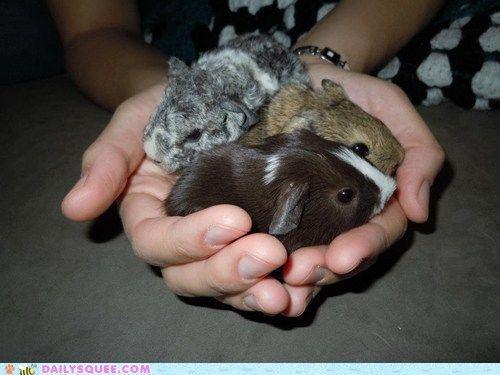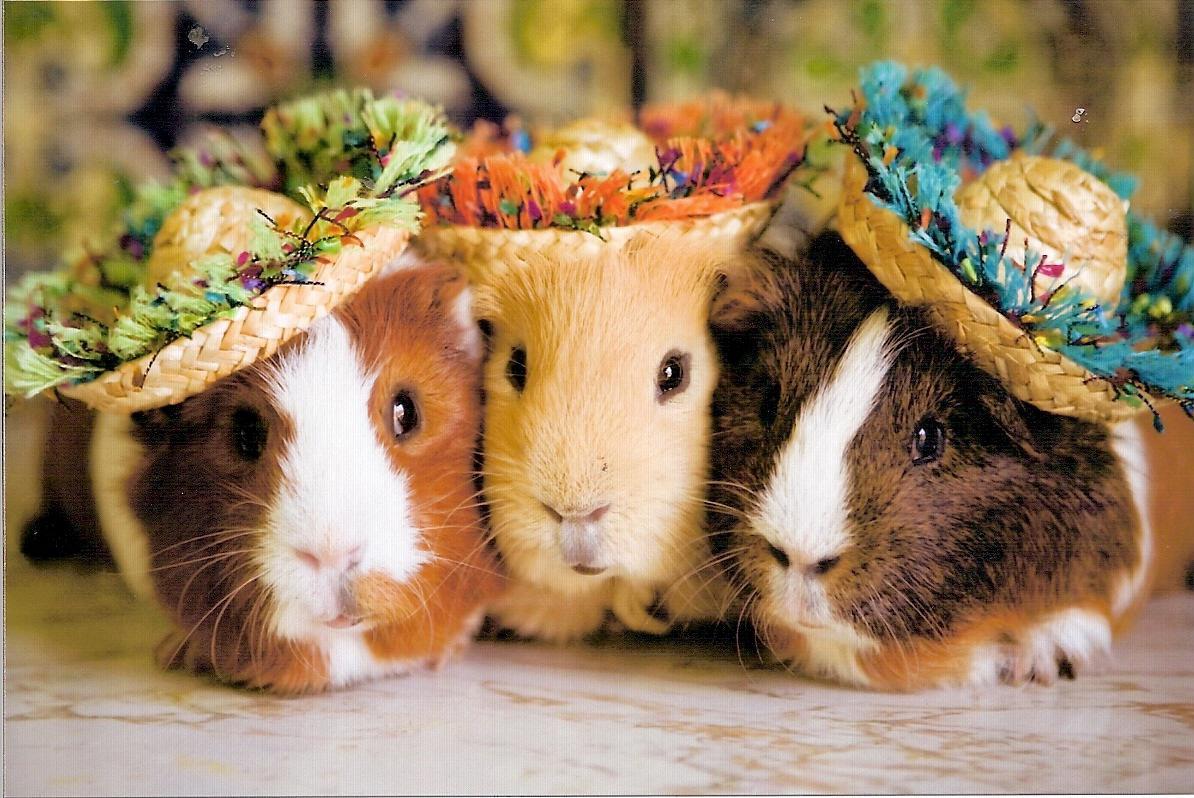The first image is the image on the left, the second image is the image on the right. Given the left and right images, does the statement "An image shows three multicolor guinea pigs posed side-by-side outdoors with greenery in the picture." hold true? Answer yes or no. No. The first image is the image on the left, the second image is the image on the right. Assess this claim about the two images: "There are 6 guinea pigs in all, the three in the image on the right are lined up side by side, looking at the camera.". Correct or not? Answer yes or no. Yes. 